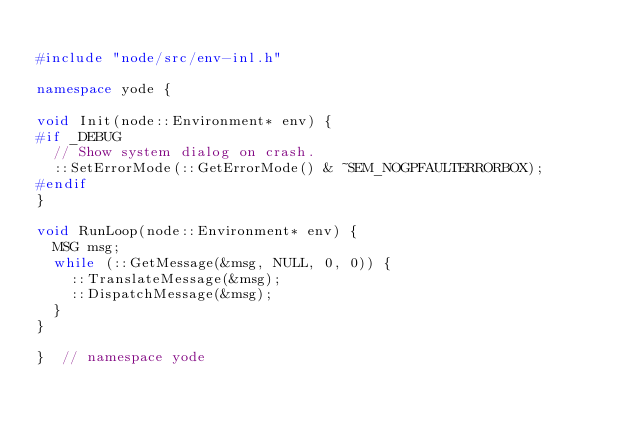<code> <loc_0><loc_0><loc_500><loc_500><_C++_>
#include "node/src/env-inl.h"

namespace yode {

void Init(node::Environment* env) {
#if _DEBUG
  // Show system dialog on crash.
  ::SetErrorMode(::GetErrorMode() & ~SEM_NOGPFAULTERRORBOX);
#endif
}

void RunLoop(node::Environment* env) {
  MSG msg;
  while (::GetMessage(&msg, NULL, 0, 0)) {
    ::TranslateMessage(&msg);
    ::DispatchMessage(&msg);
  }
}

}  // namespace yode
</code> 